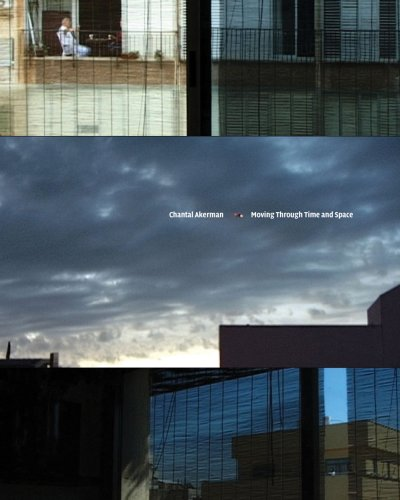Can you describe what visual elements are captured on the book cover? The book cover features a collage of various images, likely stills from Chantal Akerman's films, depicting different urban scenes and interiors, which reflect her thematic focus on personal space and memory. 